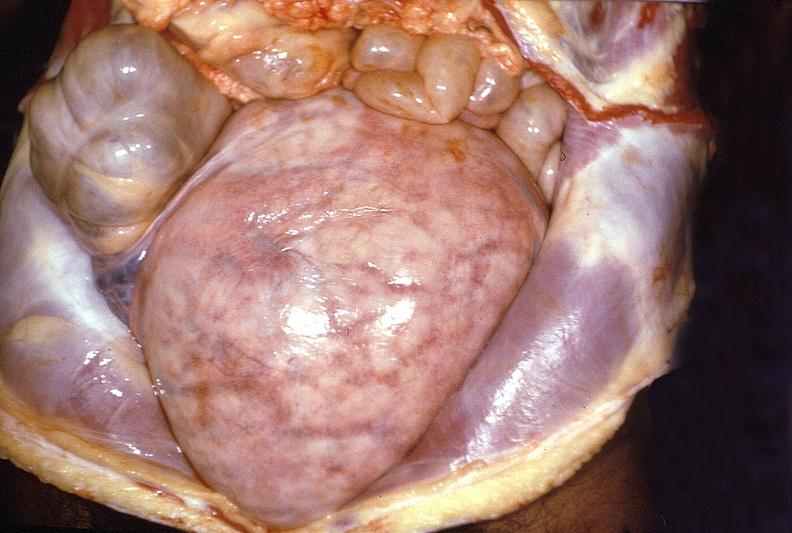does anomalous origin show gravid uterus?
Answer the question using a single word or phrase. No 